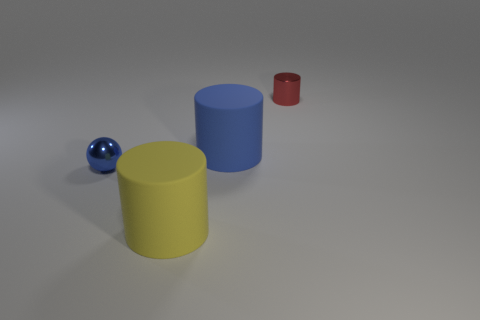What can you tell me about the sizes of the objects in comparison to each other? In comparison, the blue and yellow cylinders are the largest and appear to be similar in height, the red cylinder is the smallest, and the blue metal ball is smaller than the cylinders but similar in size to the red cylinder. How would you describe the layout of the objects? The objects are spaced apart on an even surface. From the perspective of the image, the yellow cylinder is in the foreground, the metal ball and blue cylinder are in the middle ground, and the red cylinder is in the background, creating a sense of depth. 